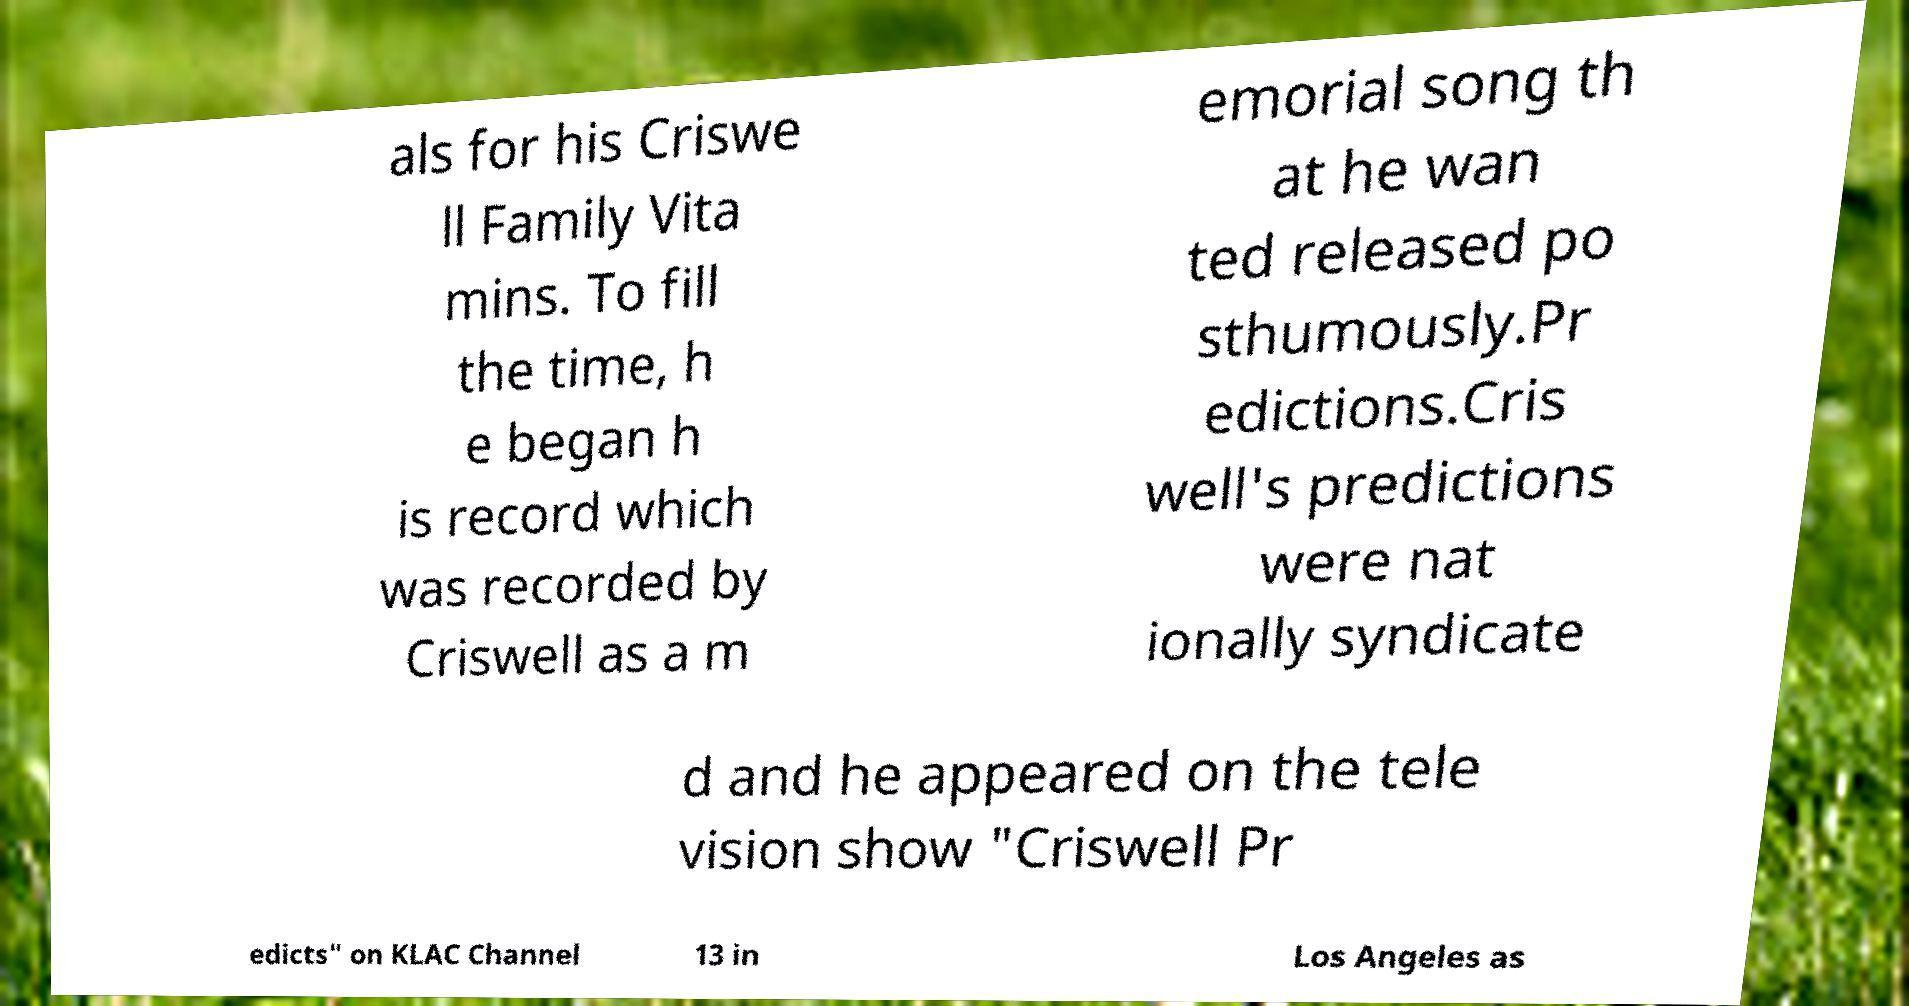For documentation purposes, I need the text within this image transcribed. Could you provide that? als for his Criswe ll Family Vita mins. To fill the time, h e began h is record which was recorded by Criswell as a m emorial song th at he wan ted released po sthumously.Pr edictions.Cris well's predictions were nat ionally syndicate d and he appeared on the tele vision show "Criswell Pr edicts" on KLAC Channel 13 in Los Angeles as 